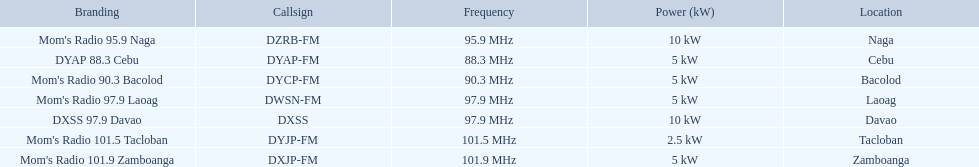Which stations use less than 10kw of power? Mom's Radio 97.9 Laoag, Mom's Radio 90.3 Bacolod, DYAP 88.3 Cebu, Mom's Radio 101.5 Tacloban, Mom's Radio 101.9 Zamboanga. Do any stations use less than 5kw of power? if so, which ones? Mom's Radio 101.5 Tacloban. 